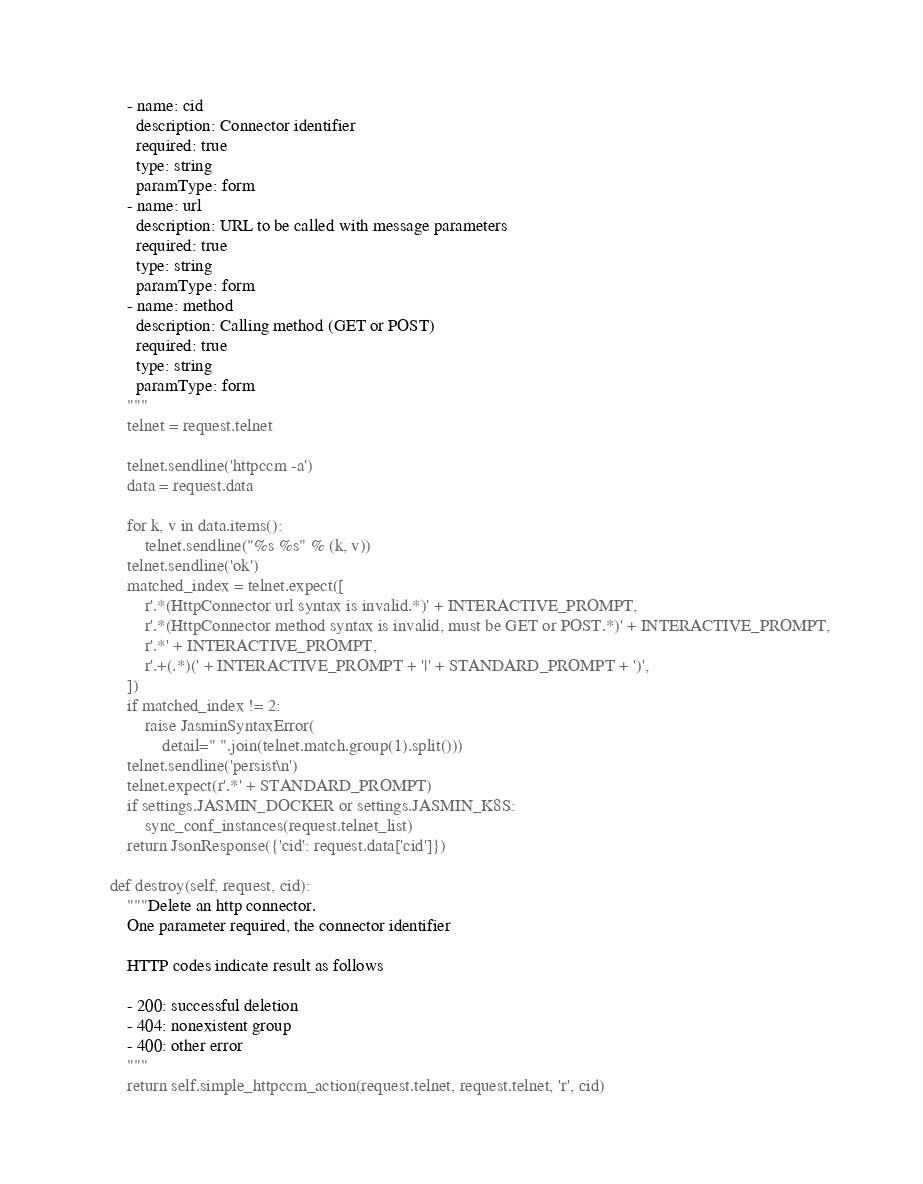<code> <loc_0><loc_0><loc_500><loc_500><_Python_>        - name: cid
          description: Connector identifier
          required: true
          type: string
          paramType: form
        - name: url
          description: URL to be called with message parameters
          required: true
          type: string
          paramType: form
        - name: method
          description: Calling method (GET or POST)
          required: true
          type: string
          paramType: form
        """
        telnet = request.telnet

        telnet.sendline('httpccm -a')
        data = request.data
	
        for k, v in data.items():
            telnet.sendline("%s %s" % (k, v))
        telnet.sendline('ok')
        matched_index = telnet.expect([
            r'.*(HttpConnector url syntax is invalid.*)' + INTERACTIVE_PROMPT,
            r'.*(HttpConnector method syntax is invalid, must be GET or POST.*)' + INTERACTIVE_PROMPT,
            r'.*' + INTERACTIVE_PROMPT,
            r'.+(.*)(' + INTERACTIVE_PROMPT + '|' + STANDARD_PROMPT + ')',
        ])
        if matched_index != 2:
            raise JasminSyntaxError(
                detail=" ".join(telnet.match.group(1).split()))
        telnet.sendline('persist\n')
        telnet.expect(r'.*' + STANDARD_PROMPT)
        if settings.JASMIN_DOCKER or settings.JASMIN_K8S:
            sync_conf_instances(request.telnet_list)
        return JsonResponse({'cid': request.data['cid']})

    def destroy(self, request, cid):
        """Delete an http connector.
        One parameter required, the connector identifier

        HTTP codes indicate result as follows

        - 200: successful deletion
        - 404: nonexistent group
        - 400: other error
        """
        return self.simple_httpccm_action(request.telnet, request.telnet, 'r', cid)

</code> 